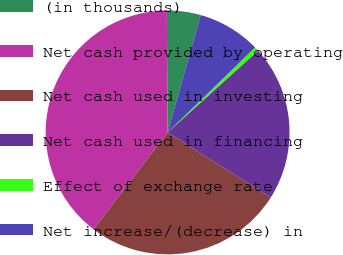Convert chart to OTSL. <chart><loc_0><loc_0><loc_500><loc_500><pie_chart><fcel>(in thousands)<fcel>Net cash provided by operating<fcel>Net cash used in investing<fcel>Net cash used in financing<fcel>Effect of exchange rate<fcel>Net increase/(decrease) in<nl><fcel>4.47%<fcel>39.5%<fcel>26.44%<fcel>20.66%<fcel>0.57%<fcel>8.36%<nl></chart> 